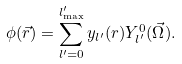<formula> <loc_0><loc_0><loc_500><loc_500>\phi ( \vec { r } ) = \sum _ { l ^ { \prime } = 0 } ^ { l ^ { \prime } _ { \max } } y _ { l ^ { \prime } } ( r ) Y _ { l ^ { \prime } } ^ { 0 } ( \vec { \Omega } ) .</formula> 